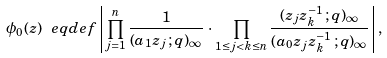Convert formula to latex. <formula><loc_0><loc_0><loc_500><loc_500>\phi _ { 0 } ( z ) \ e q d e f \left | \, \prod _ { j = 1 } ^ { n } \frac { 1 } { ( a _ { 1 } z _ { j } \, ; q ) _ { \infty } } \, \cdot \, \prod _ { 1 \leq j < k \leq n } \frac { ( z _ { j } z _ { k } ^ { - 1 } \, ; q ) _ { \infty } } { ( a _ { 0 } z _ { j } z _ { k } ^ { - 1 } \, ; q ) _ { \infty } } \, \right | ,</formula> 